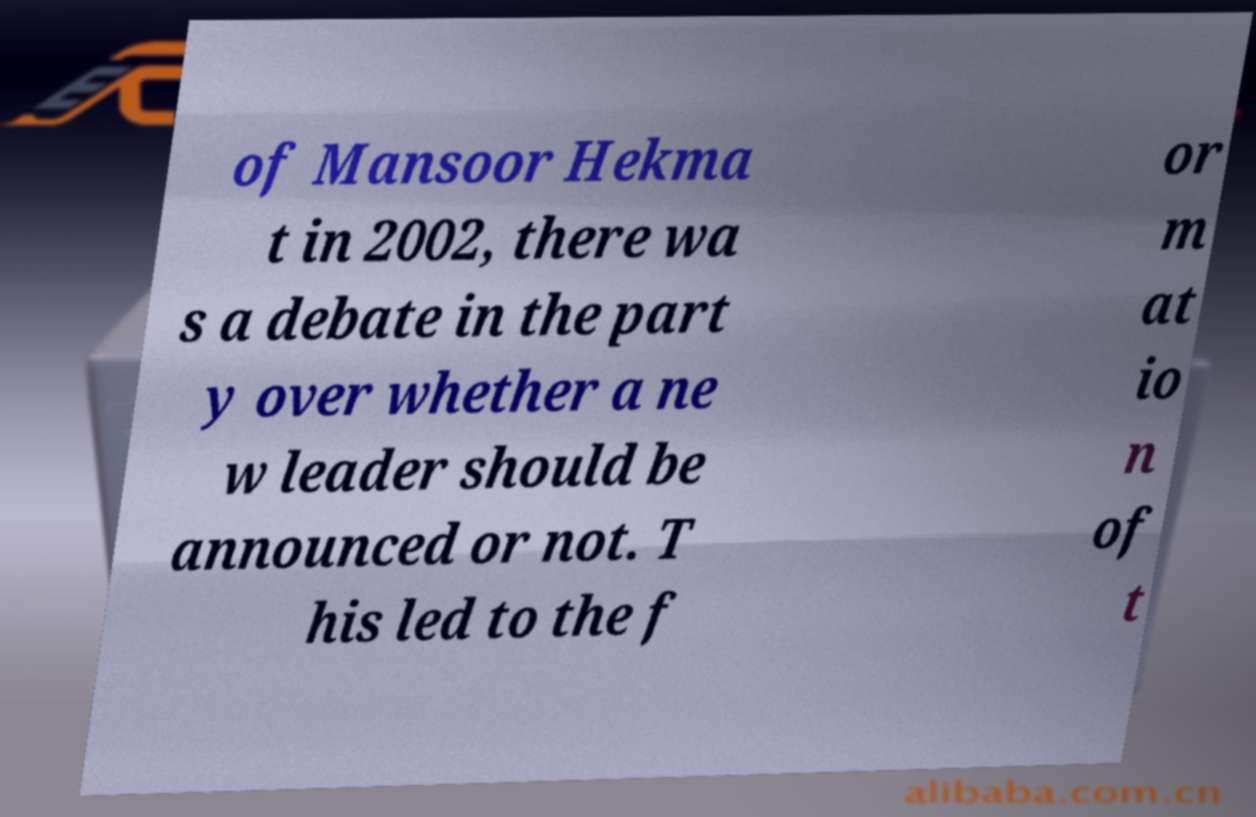What messages or text are displayed in this image? I need them in a readable, typed format. of Mansoor Hekma t in 2002, there wa s a debate in the part y over whether a ne w leader should be announced or not. T his led to the f or m at io n of t 